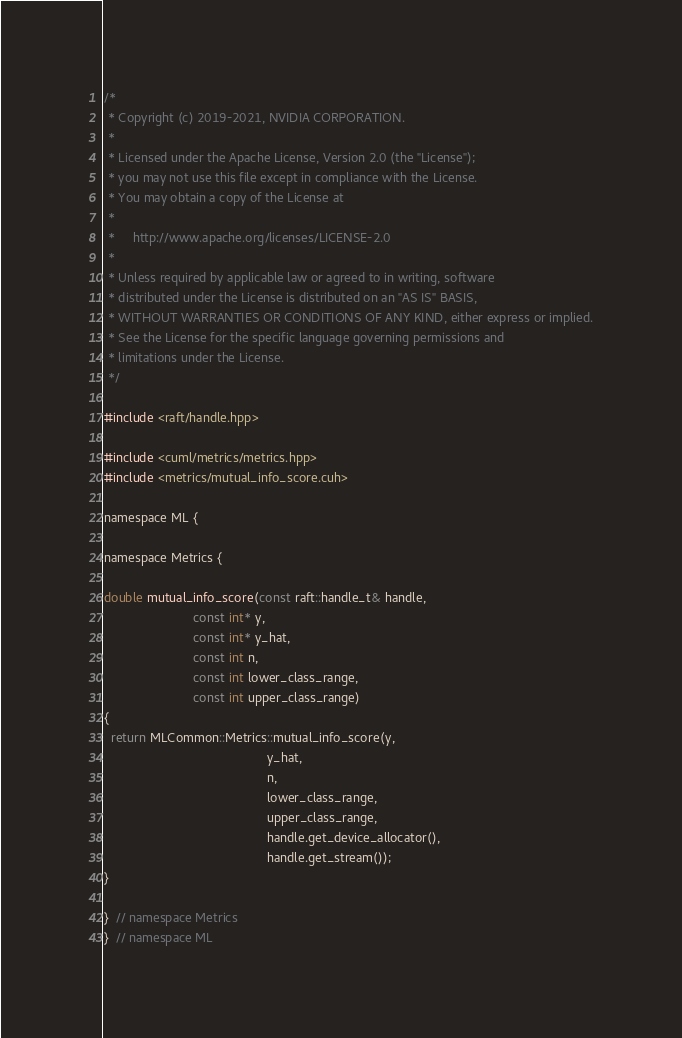Convert code to text. <code><loc_0><loc_0><loc_500><loc_500><_Cuda_>
/*
 * Copyright (c) 2019-2021, NVIDIA CORPORATION.
 *
 * Licensed under the Apache License, Version 2.0 (the "License");
 * you may not use this file except in compliance with the License.
 * You may obtain a copy of the License at
 *
 *     http://www.apache.org/licenses/LICENSE-2.0
 *
 * Unless required by applicable law or agreed to in writing, software
 * distributed under the License is distributed on an "AS IS" BASIS,
 * WITHOUT WARRANTIES OR CONDITIONS OF ANY KIND, either express or implied.
 * See the License for the specific language governing permissions and
 * limitations under the License.
 */

#include <raft/handle.hpp>

#include <cuml/metrics/metrics.hpp>
#include <metrics/mutual_info_score.cuh>

namespace ML {

namespace Metrics {

double mutual_info_score(const raft::handle_t& handle,
                         const int* y,
                         const int* y_hat,
                         const int n,
                         const int lower_class_range,
                         const int upper_class_range)
{
  return MLCommon::Metrics::mutual_info_score(y,
                                              y_hat,
                                              n,
                                              lower_class_range,
                                              upper_class_range,
                                              handle.get_device_allocator(),
                                              handle.get_stream());
}

}  // namespace Metrics
}  // namespace ML
</code> 